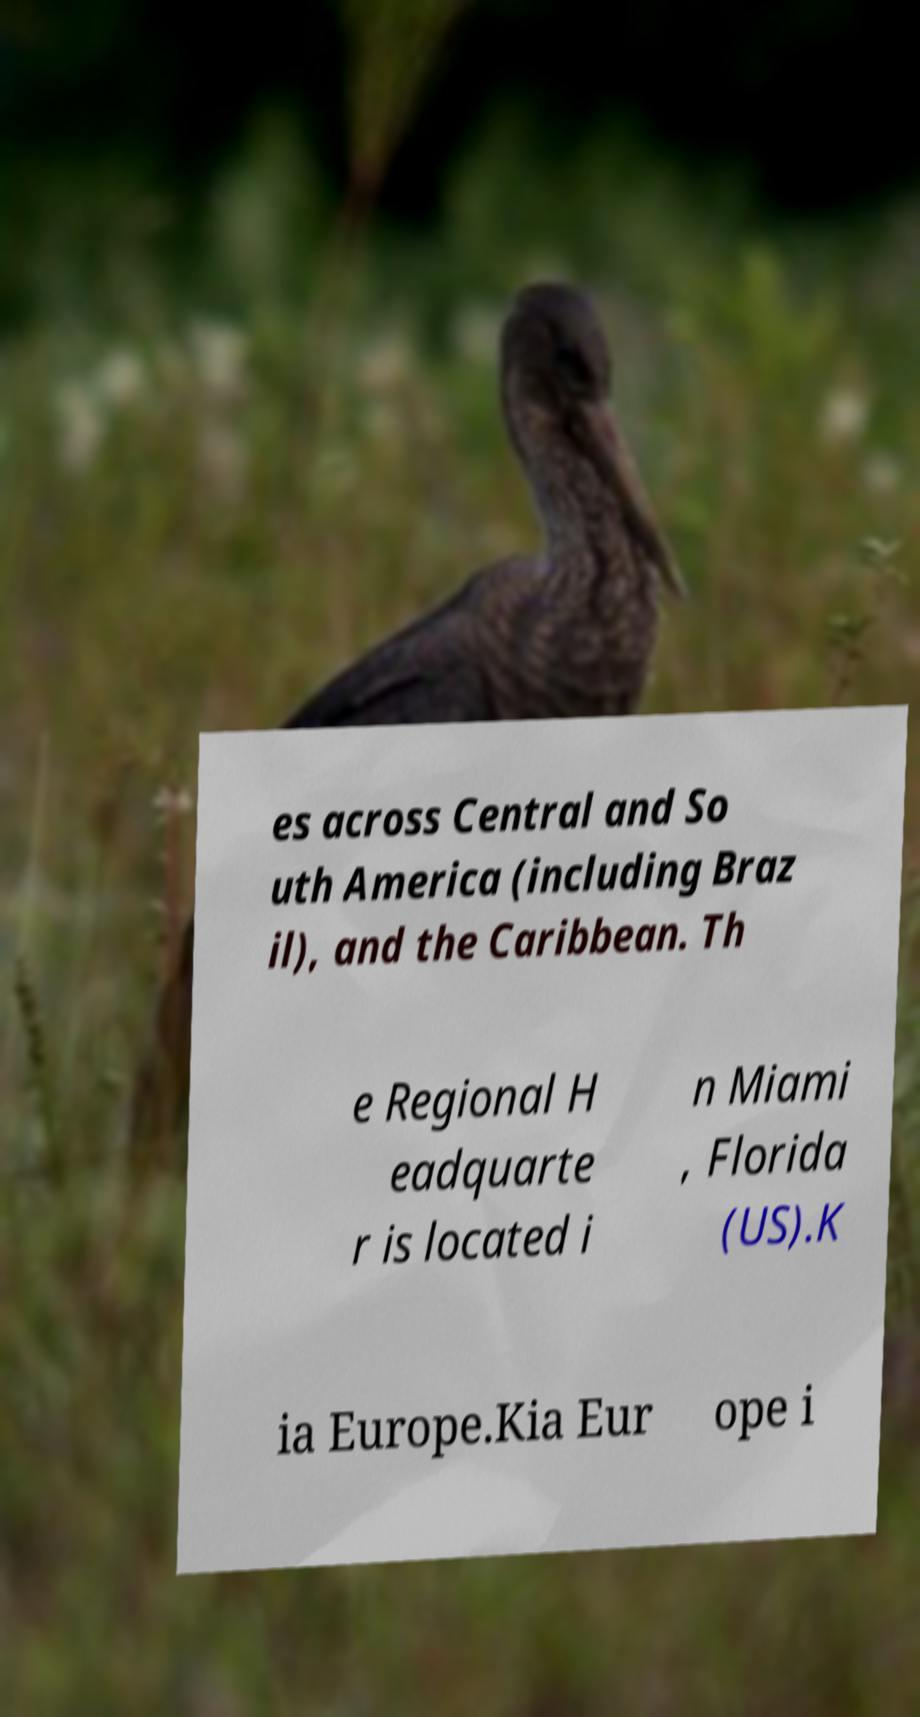What messages or text are displayed in this image? I need them in a readable, typed format. es across Central and So uth America (including Braz il), and the Caribbean. Th e Regional H eadquarte r is located i n Miami , Florida (US).K ia Europe.Kia Eur ope i 